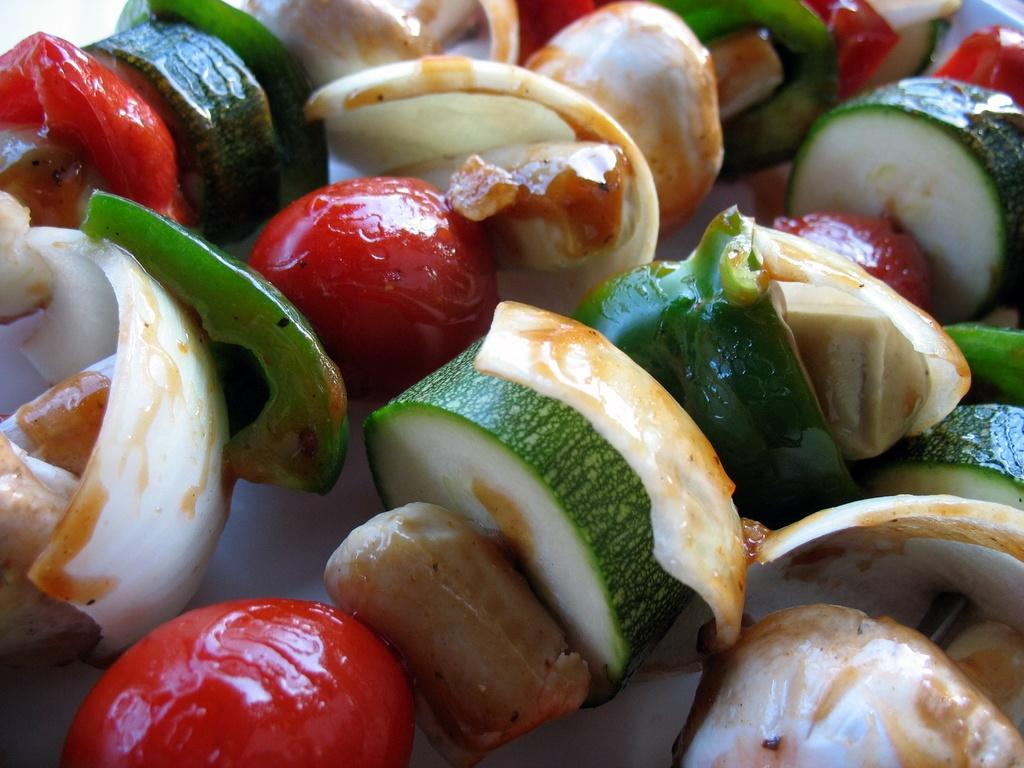What types of food items can be seen in the image? The food items in the image have red, green, and white colors. What is the color of the surface on which the food items are placed? The food items are on a white surface. What type of cushion is visible in the image? There is no cushion present in the image. What type of flesh can be seen in the image? There is no flesh present in the image; it features food items with red, green, and white colors. 